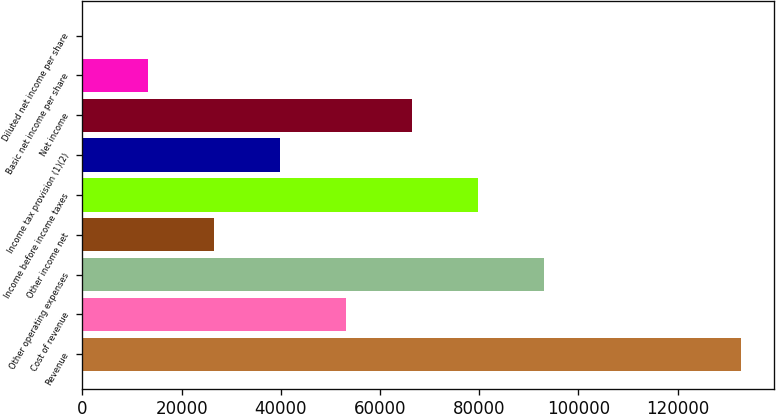<chart> <loc_0><loc_0><loc_500><loc_500><bar_chart><fcel>Revenue<fcel>Cost of revenue<fcel>Other operating expenses<fcel>Other income net<fcel>Income before income taxes<fcel>Income tax provision (1)(2)<fcel>Net income<fcel>Basic net income per share<fcel>Diluted net income per share<nl><fcel>132823<fcel>53129.5<fcel>92976.3<fcel>26565<fcel>79694<fcel>39847.3<fcel>66411.8<fcel>13282.8<fcel>0.54<nl></chart> 